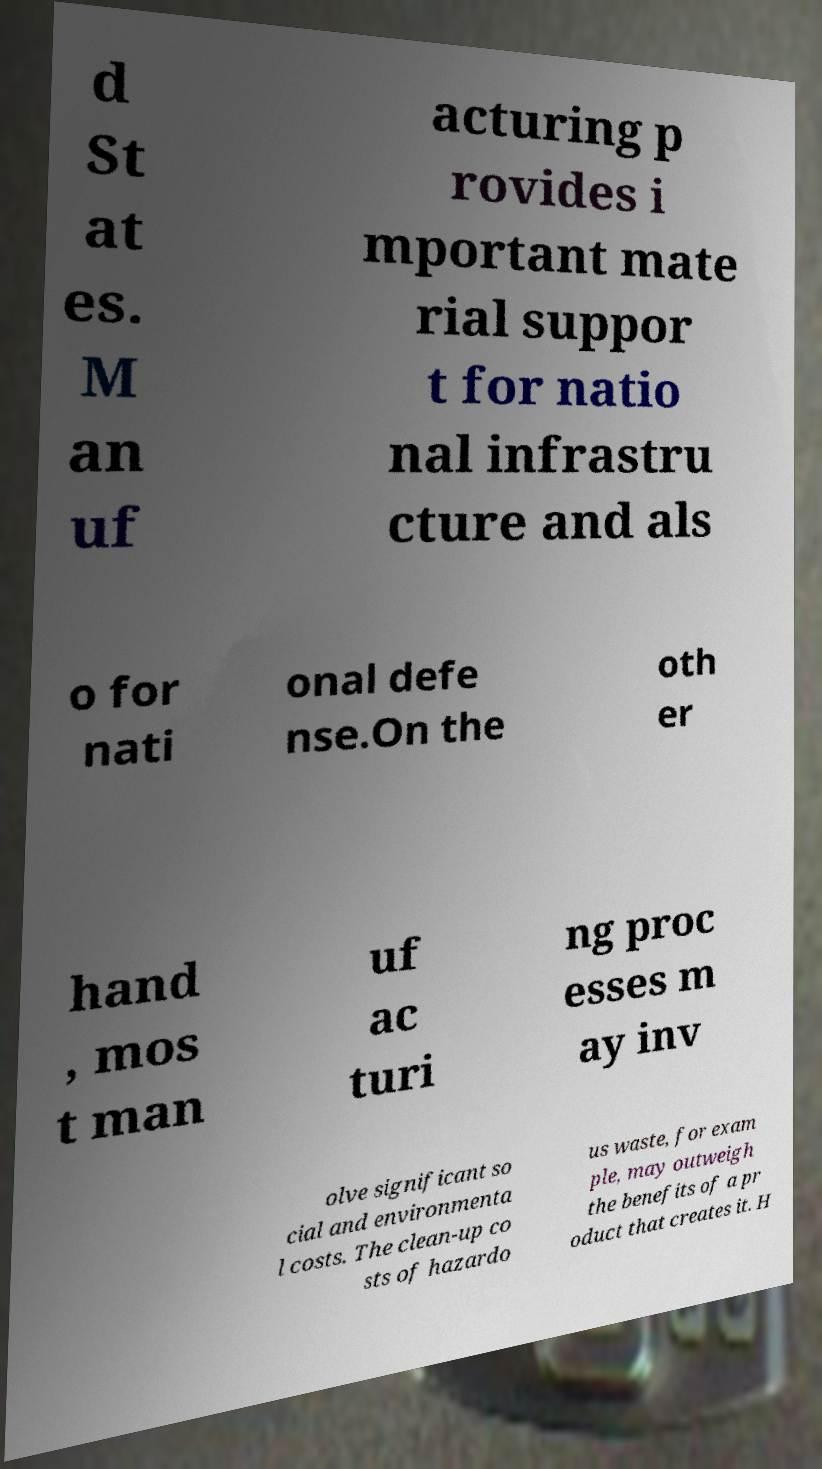Could you extract and type out the text from this image? d St at es. M an uf acturing p rovides i mportant mate rial suppor t for natio nal infrastru cture and als o for nati onal defe nse.On the oth er hand , mos t man uf ac turi ng proc esses m ay inv olve significant so cial and environmenta l costs. The clean-up co sts of hazardo us waste, for exam ple, may outweigh the benefits of a pr oduct that creates it. H 